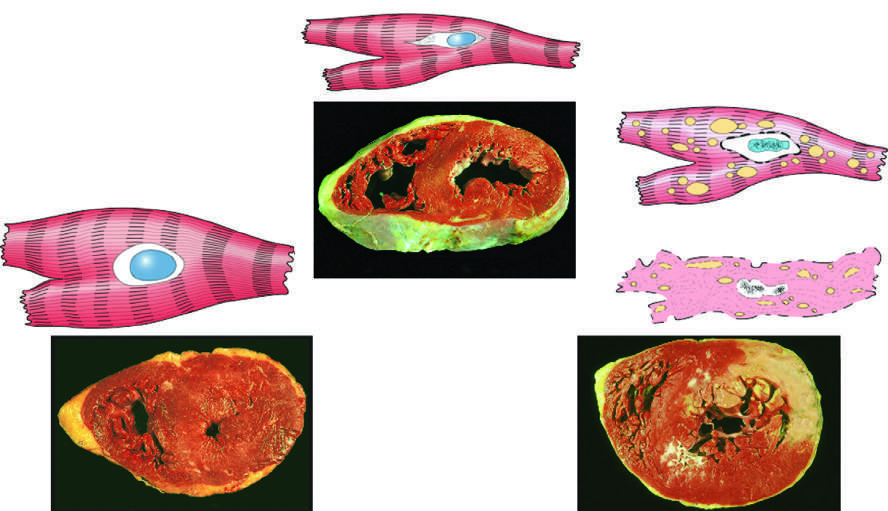were all three transverse sections of myocardium stained with triphenyltetra-zolium chloride, an enzyme substrate that colors viable myocardium magenta?
Answer the question using a single word or phrase. Yes 